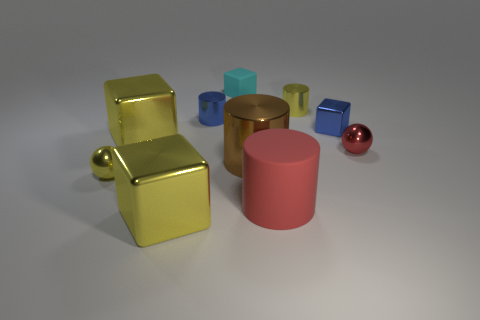What number of large things are brown things or blue shiny objects?
Your answer should be compact. 1. There is a tiny block that is the same material as the yellow ball; what is its color?
Your answer should be compact. Blue. What is the color of the tiny shiny object in front of the red shiny object?
Give a very brief answer. Yellow. How many objects are the same color as the rubber cylinder?
Offer a terse response. 1. Is the number of brown cylinders that are to the left of the tiny red ball less than the number of cyan objects on the left side of the small matte thing?
Offer a terse response. No. What number of metal blocks are on the right side of the red cylinder?
Your response must be concise. 1. Are there any big red cylinders made of the same material as the cyan block?
Provide a succinct answer. Yes. Is the number of tiny blocks that are behind the blue block greater than the number of big rubber things to the left of the yellow sphere?
Offer a terse response. Yes. What size is the blue cylinder?
Offer a very short reply. Small. What is the shape of the blue object that is left of the large matte cylinder?
Your response must be concise. Cylinder. 